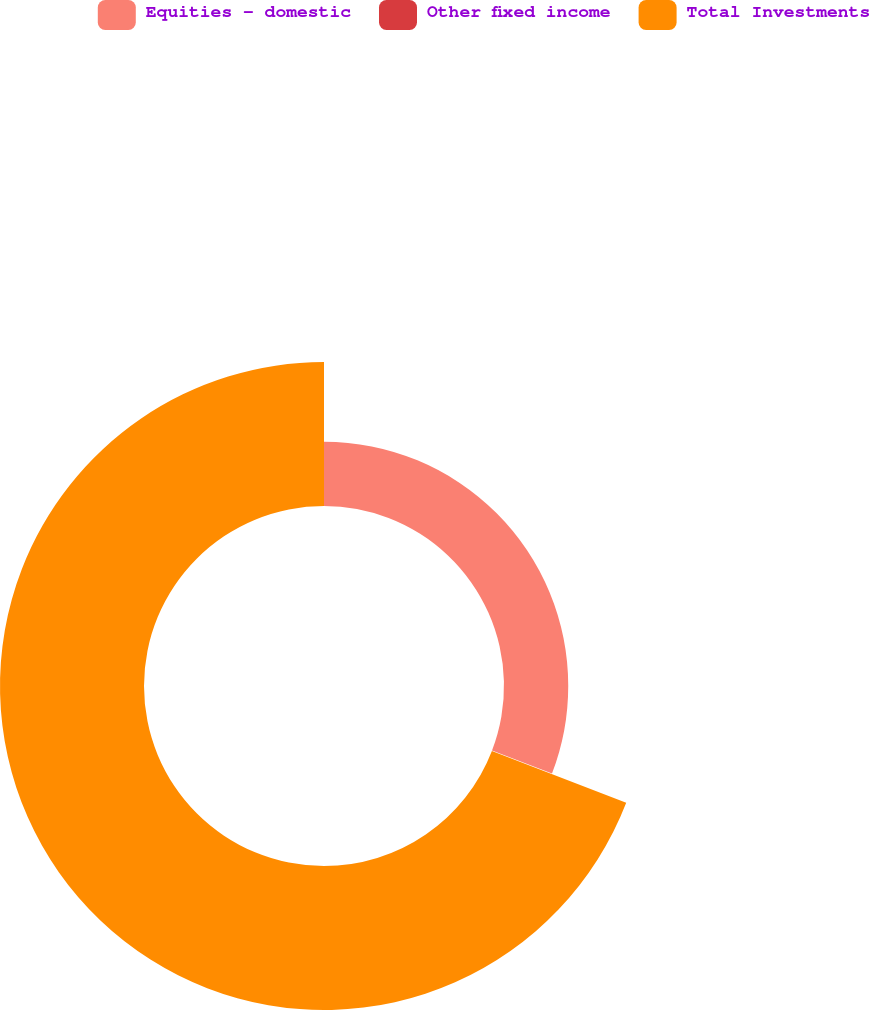<chart> <loc_0><loc_0><loc_500><loc_500><pie_chart><fcel>Equities - domestic<fcel>Other fixed income<fcel>Total Investments<nl><fcel>30.84%<fcel>0.03%<fcel>69.13%<nl></chart> 